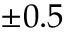Convert formula to latex. <formula><loc_0><loc_0><loc_500><loc_500>\pm 0 . 5</formula> 